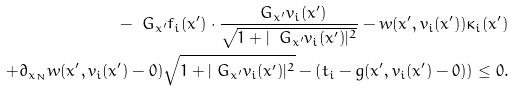Convert formula to latex. <formula><loc_0><loc_0><loc_500><loc_500>- \ G _ { x ^ { \prime } } f _ { i } ( x ^ { \prime } ) \cdot \frac { \ G _ { x ^ { \prime } } v _ { i } ( x ^ { \prime } ) } { \sqrt { 1 + | \ G _ { x ^ { \prime } } v _ { i } ( x ^ { \prime } ) | ^ { 2 } } } - w ( x ^ { \prime } , v _ { i } ( x ^ { \prime } ) ) \kappa _ { i } ( x ^ { \prime } ) \\ + \partial _ { x _ { N } } w ( x ^ { \prime } , v _ { i } ( x ^ { \prime } ) - 0 ) \sqrt { 1 + | \ G _ { { x } ^ { \prime } } v _ { i } ( x ^ { \prime } ) | ^ { 2 } } - \left ( t _ { i } - g ( x ^ { \prime } , v _ { i } ( x ^ { \prime } ) - 0 ) \right ) \leq 0 .</formula> 